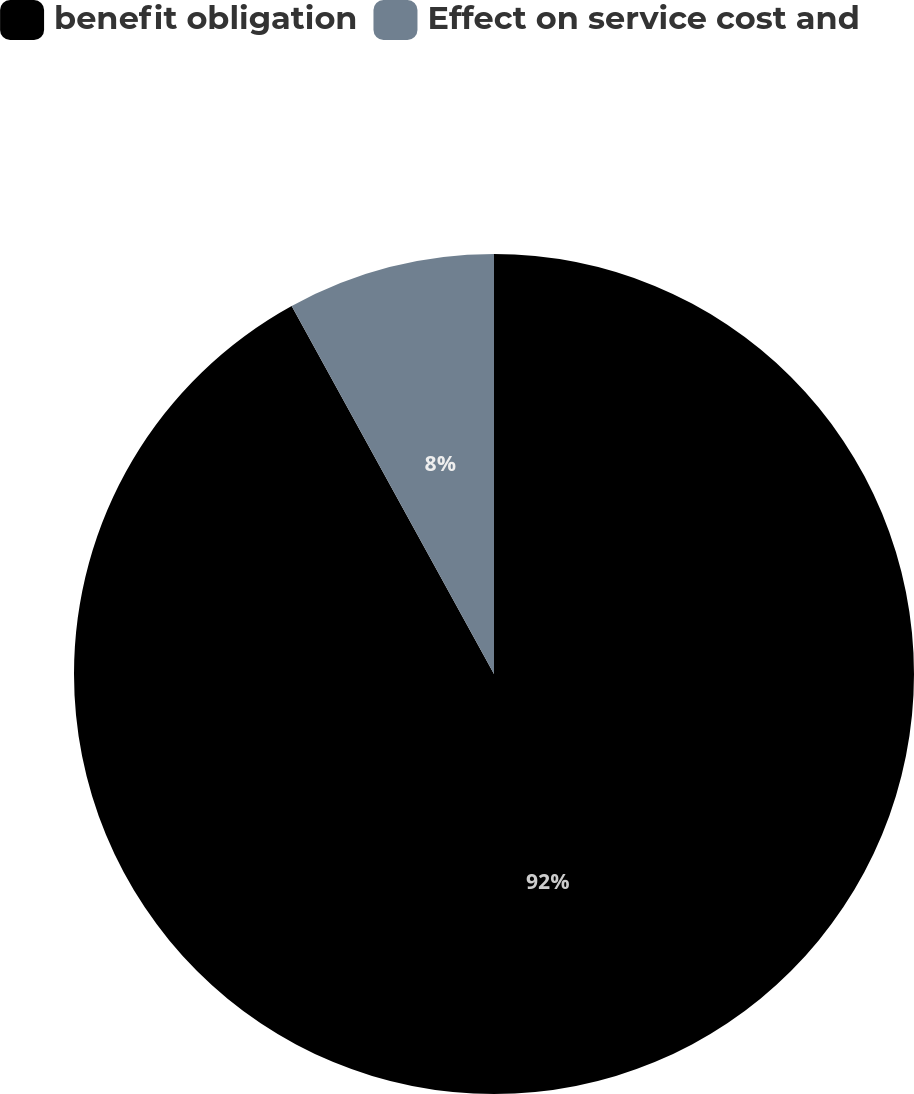Convert chart to OTSL. <chart><loc_0><loc_0><loc_500><loc_500><pie_chart><fcel>benefit obligation<fcel>Effect on service cost and<nl><fcel>92.0%<fcel>8.0%<nl></chart> 